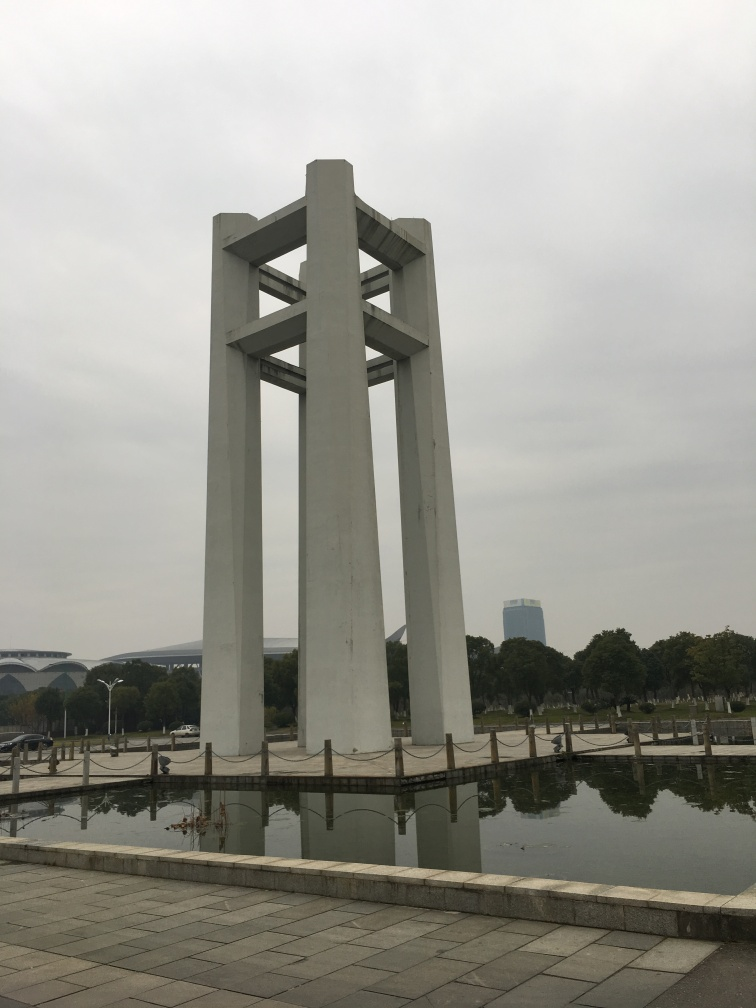How does this image make you feel? While I don't experience emotions, the elements in the image could evoke a sense of peacefulness and contemplation. The calm water, the grandeur of the structure, and the subdued colors under the cloudy sky all contribute to a quiet and introspective atmosphere. 